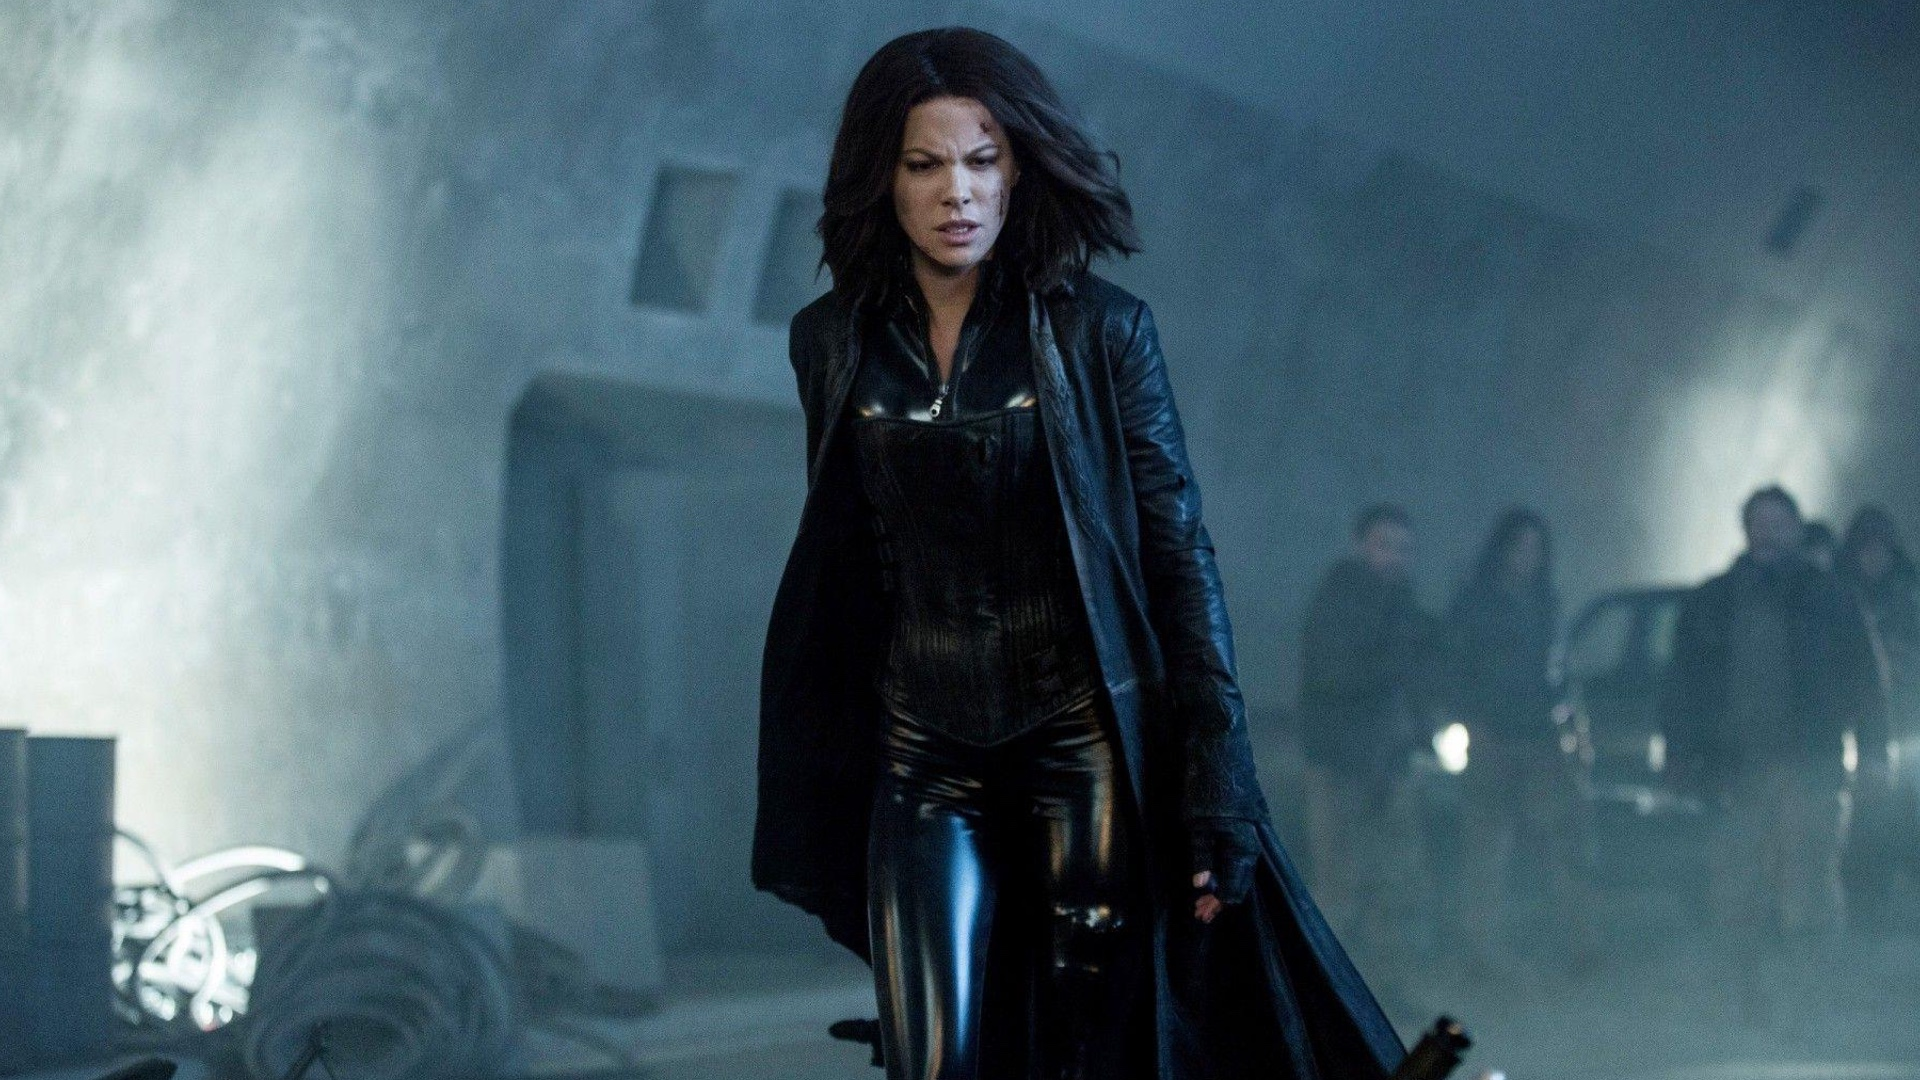What if Selene could interact with another movie character from a different series? What if Selene could interact with Neo from the Matrix series? Imagine a crossover where Selene and Neo team up to face a hybrid threat that spans both the Underworld and Matrix universes. Their combined skills, with Selene's prowess in combat and Neo's mastery over digital realities, would create an unstoppable force against any adversary. Their interaction could lead to intense, visually stunning battles and a deeper exploration of themes like destiny, free will, and the nature of reality. This crossover would not only bring two iconic characters together but also blend their distinct worlds into a thrilling and mind-bending adventure. 